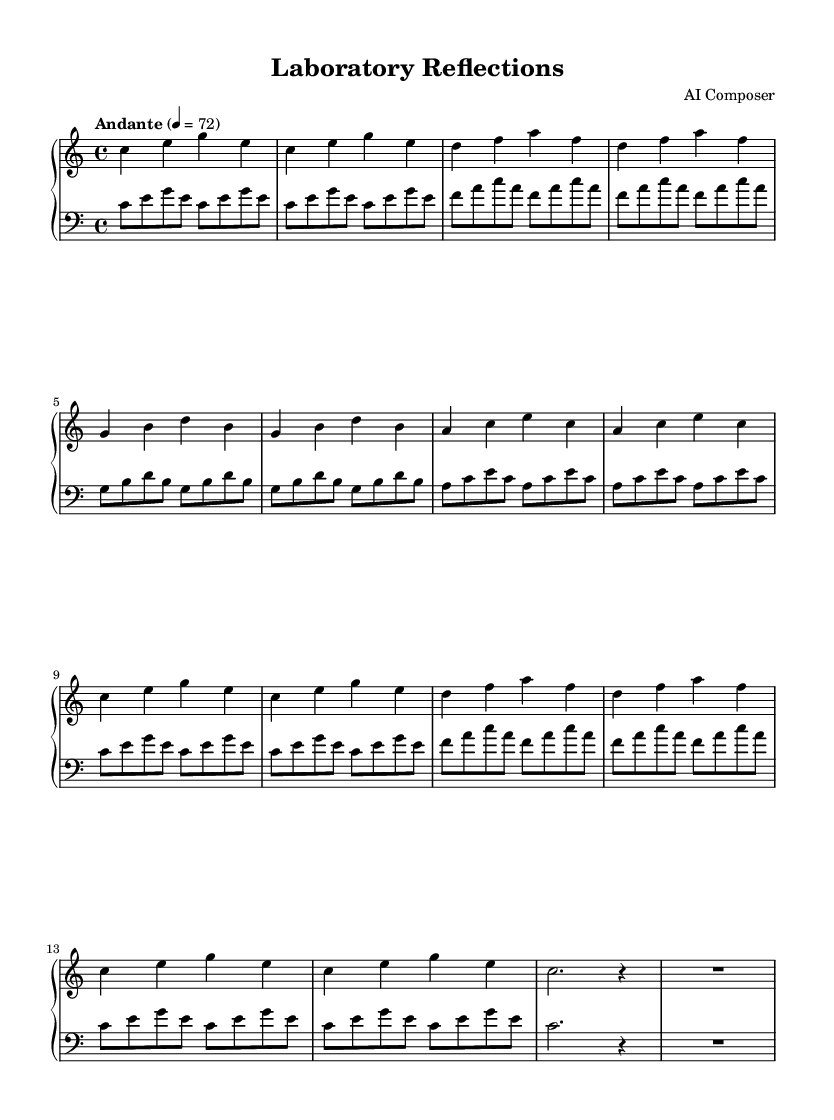What is the key signature of this music? The key signature is C major, which has no sharps or flats.
Answer: C major What is the time signature of this piece? The time signature is indicated at the beginning of the score as 4/4, which means there are four beats in a measure.
Answer: 4/4 What is the tempo marking indicated in the score? The tempo marking is "Andante," indicating a moderate pace, typically around 72 beats per minute.
Answer: Andante How many sections are there in this piece? The music contains four distinct sections labeled A, B, A', and Coda, which are specified in the structure of the music.
Answer: Four In which section does the following motif first appear: "c e g e"? This motif first appears in the section labeled A, which features the notes as the main theme throughout the section.
Answer: A What does the "R" symbol indicate in the coda? The "R" symbol signifies a rest, indicating silence for a certain duration, specifically a whole measure in this case.
Answer: Rest What is the main vocal pattern of the left hand in section A? The left hand plays a repetitive pattern with eighth notes that emphasize the tonic, major third, and fifth intervals.
Answer: Repetitive eighth notes 